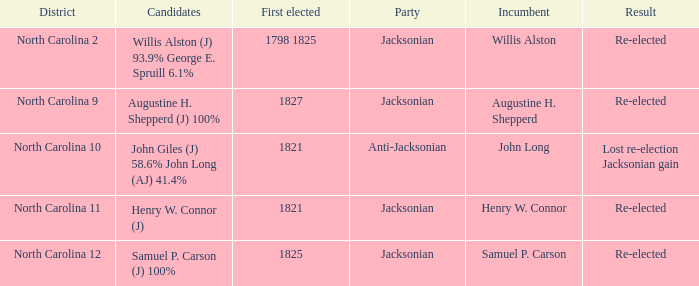Name the result for willis alston Re-elected. 